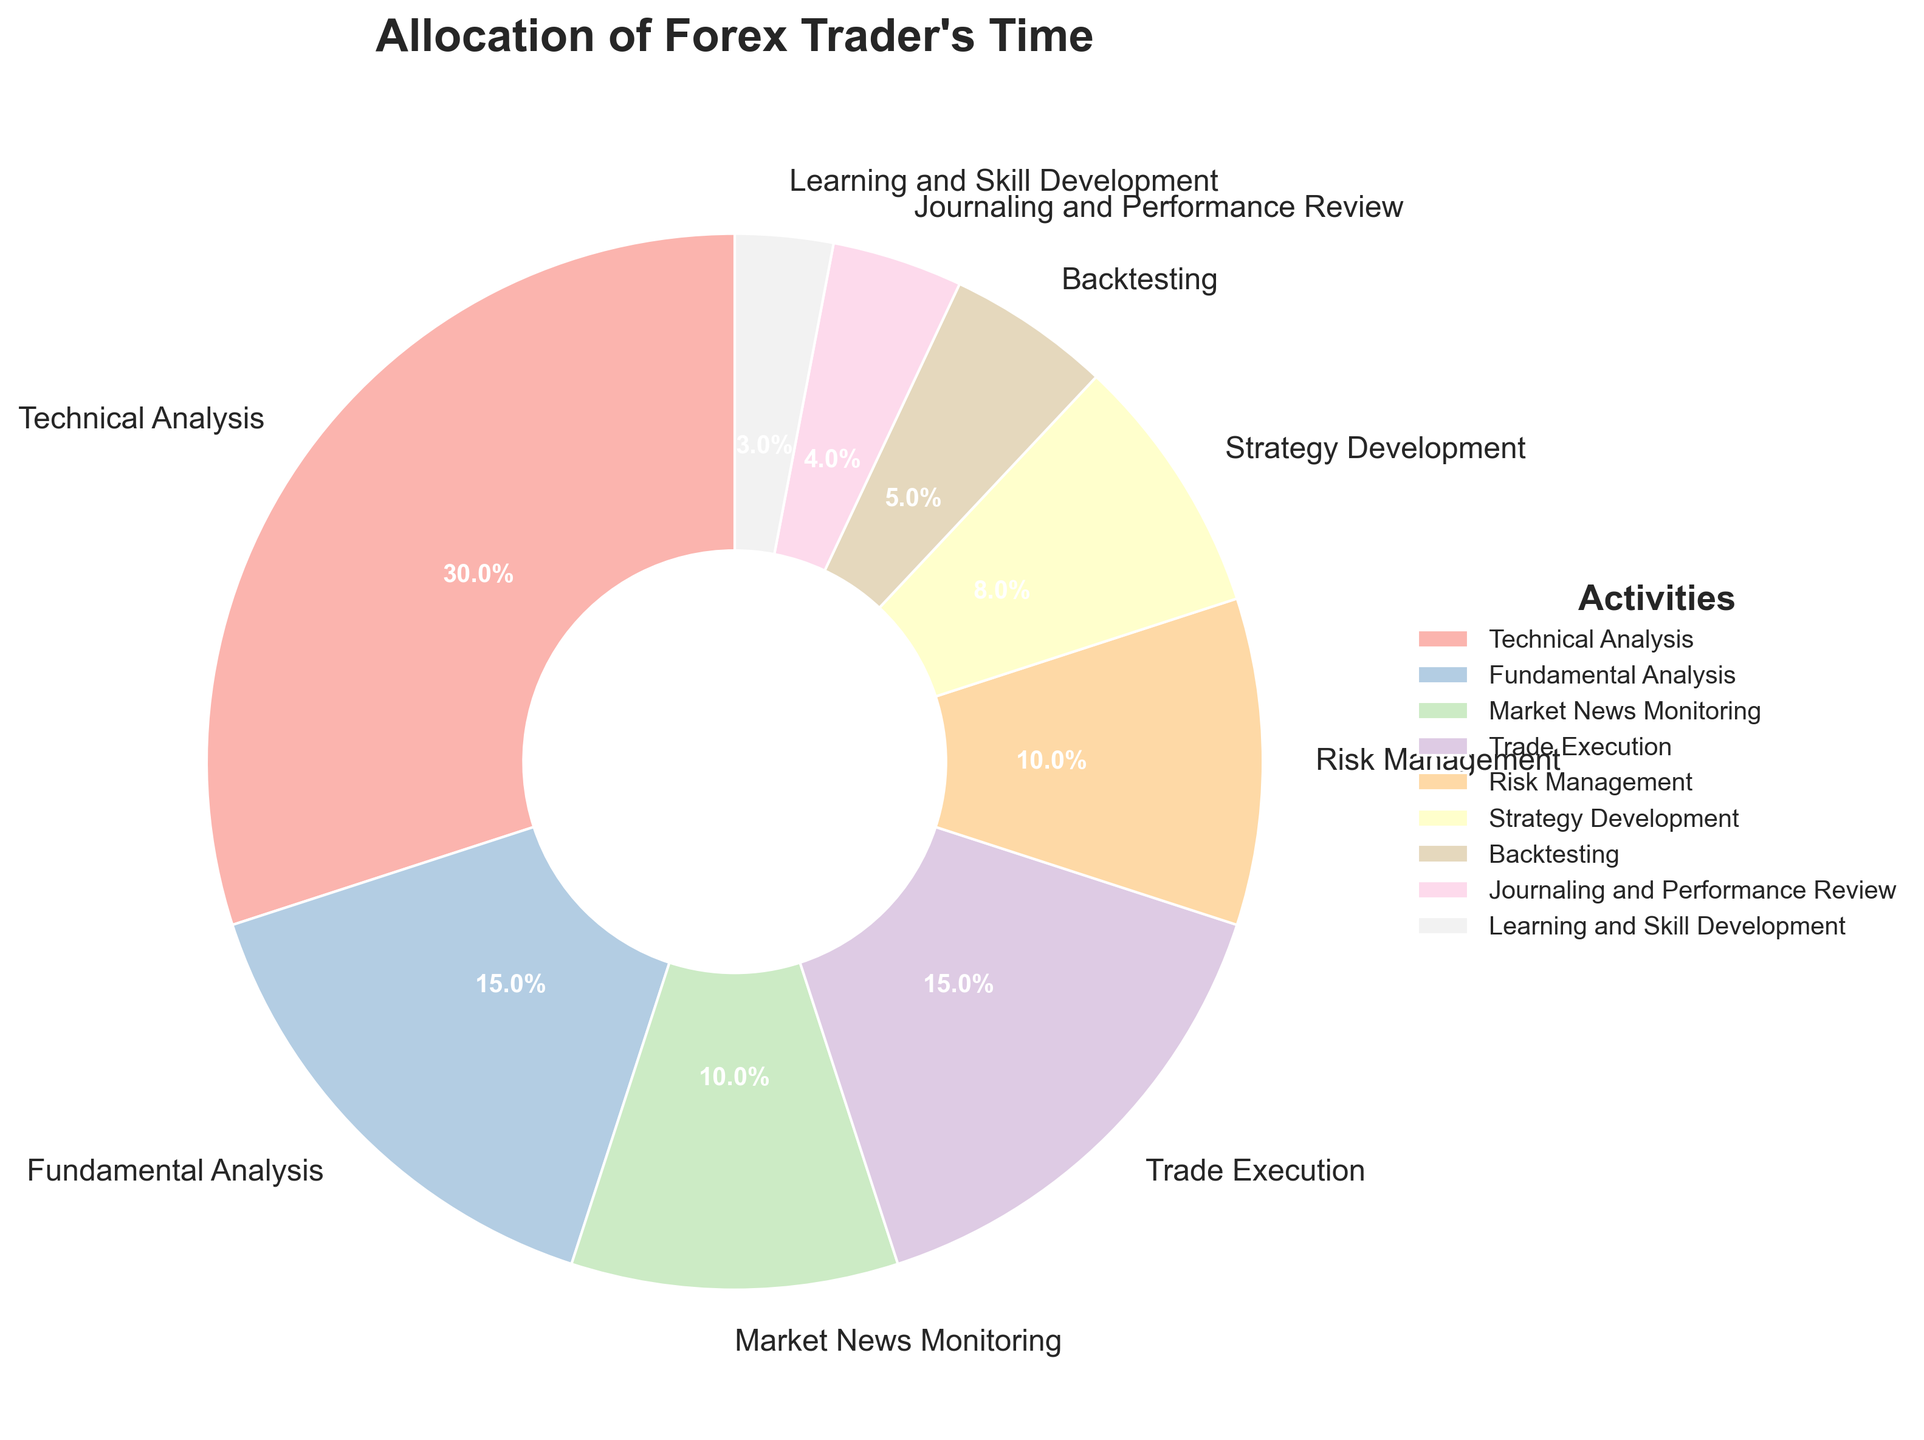What percentage of time is allocated to Technical Analysis? The percentage is directly stated in the figure as the slice labeled "Technical Analysis".
Answer: 30% How much more time is spent on Technical Analysis compared to Fundamental Analysis? According to the figure, Technical Analysis is allocated 30% of the time, and Fundamental Analysis is allocated 15%. Subtraction gives us 30% - 15% = 15%.
Answer: 15% Which activity has the smallest percentage of time allocation? By comparing all slices in the pie chart, "Learning and Skill Development" has the smallest slice, representing 3% of the time.
Answer: Learning and Skill Development What is the combined percentage of time spent on Trade Execution and Risk Management? From the chart, Trade Execution is 15% and Risk Management is 10%. Adding these gives us 15% + 10% = 25%.
Answer: 25% Is the percentage of time spent on Market News Monitoring greater than or equal to the time spent on Strategy Development? According to the chart, Market News Monitoring is 10% and Strategy Development is 8%. Comparing these values shows that 10% is greater than 8%.
Answer: Yes What is the total percentage of time spent on activities related to analysis (Technical and Fundamental)? Technical Analysis is 30% and Fundamental Analysis is 15%. Adding these gives us 30% + 15% = 45%.
Answer: 45% How do the activities labeled with double digits (percentages ≥ 10%) compare in terms of color intensity? Visual inspection of the pie chart's slices shows that the activities with double-digit percentages (Technical Analysis, Fundamental Analysis, Market News Monitoring, Trade Execution, Risk Management) all have distinct pastel colors, indicating there is no specific visual intensity pattern that differentiates them based on percentage alone.
Answer: No specific pattern What is the second-highest activity in terms of time spent? The pie chart shows that Technical Analysis is the highest at 30%. The next largest slice is for Fundamental Analysis at 15%.
Answer: Fundamental Analysis How much time difference is there between the most time-consuming activity and the least? Technical Analysis, the most time-consuming activity, is allocated 30%, while Learning and Skill Development, the least time-consuming, is 3%. The difference is 30% - 3% = 27%.
Answer: 27% Which activities combined account for less time than Trade Execution alone? Trade Execution is given 15%. Adding smaller activities: Backtesting (5%), Journaling and Performance Review (4%), and Learning and Skill Development (3%), gives us 5% + 4% + 3% = 12%, which is less than 15%.
Answer: Backtesting, Journaling and Performance Review, Learning and Skill Development 